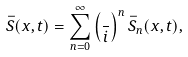Convert formula to latex. <formula><loc_0><loc_0><loc_500><loc_500>\bar { S } ( x , t ) = \sum _ { n = 0 } ^ { \infty } \left ( \frac { } { i } \right ) ^ { n } \bar { S } _ { n } ( x , t ) ,</formula> 